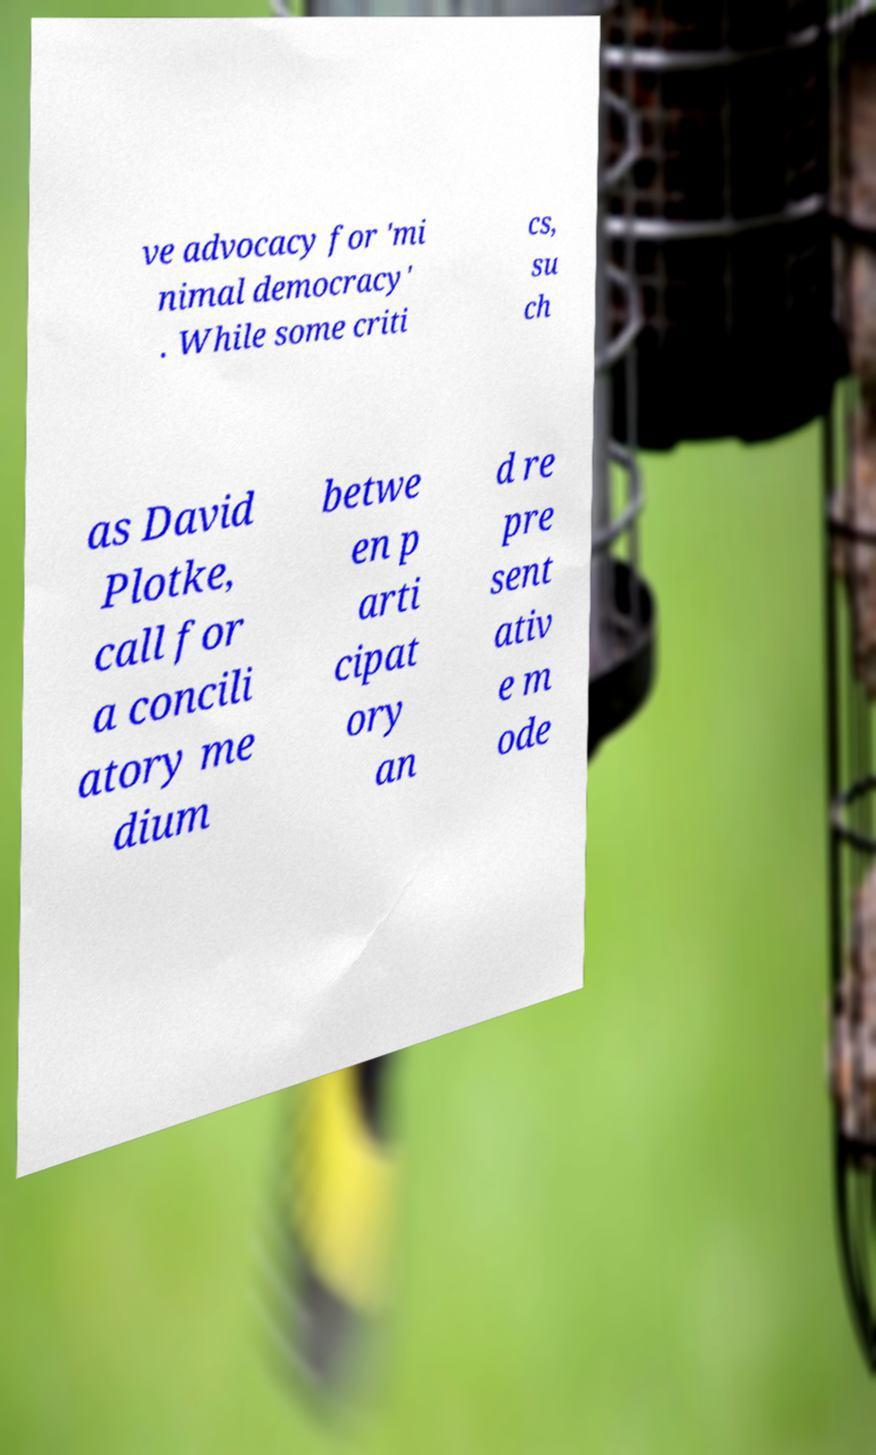For documentation purposes, I need the text within this image transcribed. Could you provide that? ve advocacy for 'mi nimal democracy' . While some criti cs, su ch as David Plotke, call for a concili atory me dium betwe en p arti cipat ory an d re pre sent ativ e m ode 